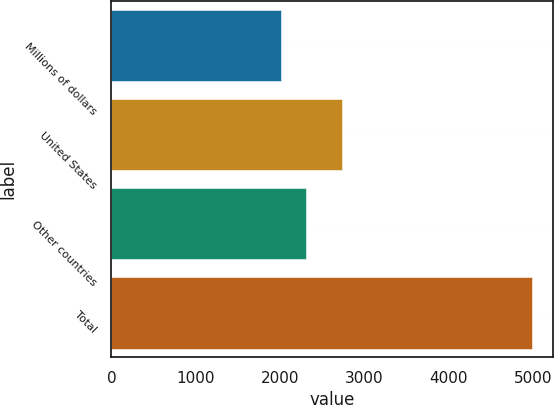Convert chart. <chart><loc_0><loc_0><loc_500><loc_500><bar_chart><fcel>Millions of dollars<fcel>United States<fcel>Other countries<fcel>Total<nl><fcel>2007<fcel>2733<fcel>2305.9<fcel>4996<nl></chart> 